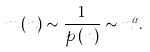Convert formula to latex. <formula><loc_0><loc_0><loc_500><loc_500>m \left ( n \right ) \sim \frac { 1 } { p \left ( n \right ) } \sim n ^ { \alpha } .</formula> 